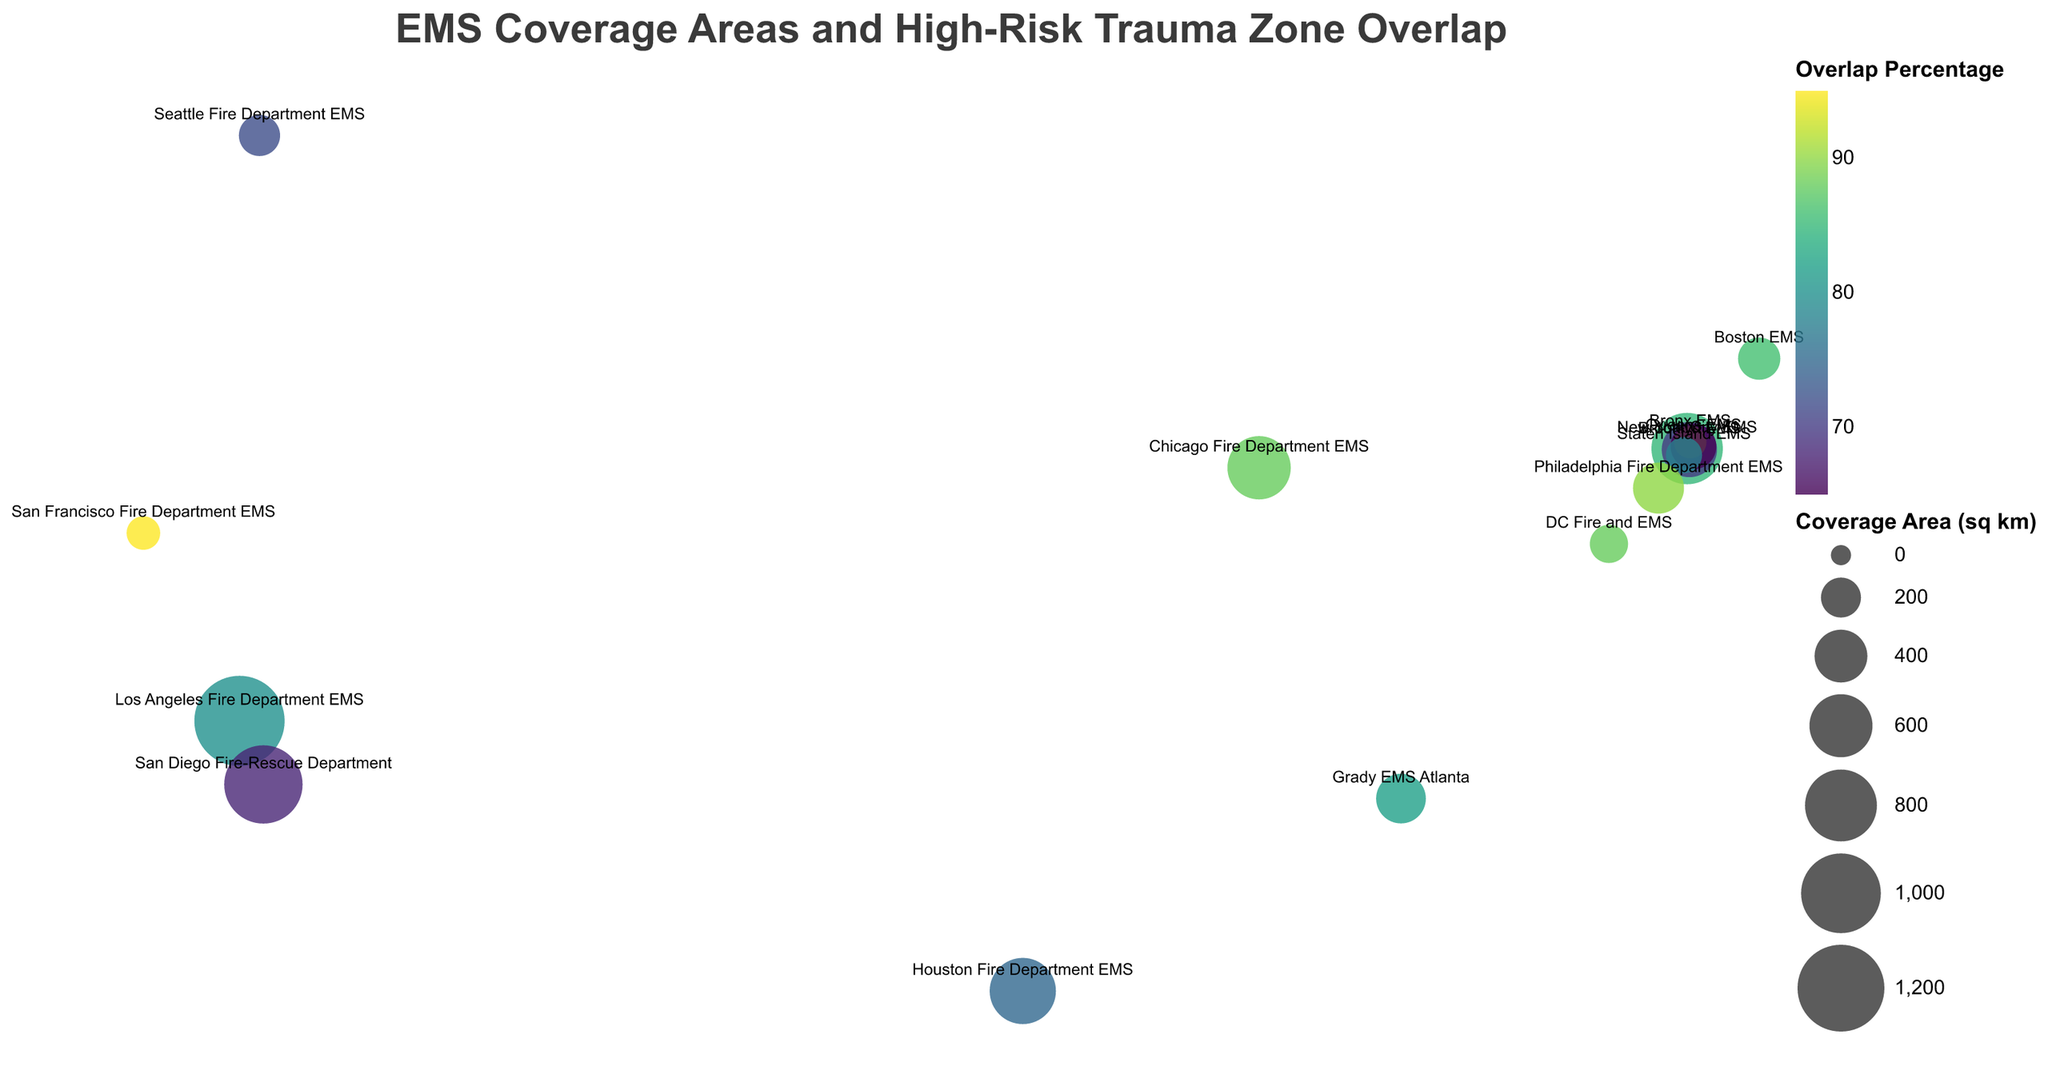What's the title of the figure? The title is located at the top center of the figure.
Answer: "EMS Coverage Areas and High-Risk Trauma Zone Overlap" How many EMS providers are displayed in the figure? The figure uses distinct markers for each EMS provider labeled by city names. Counting these labels gives the total number of EMS providers.
Answer: 15 Which EMS provider has the highest overlap percentage with high-risk trauma zones? The overlap percentage is indicated by the color of the circles. By referring to the color scale, the darkest shade corresponds to the highest overlap percentage. The tooltip can also help find the exact EMS provider.
Answer: San Francisco Fire Department EMS What is the overlap percentage of New York City EMS? Locate New York City EMS on the map, and refer to the tooltip, which will show the overlap percentage directly.
Answer: 85% Which EMS provider covers the smallest area in square kilometers? The size of the circles correlates with the coverage area. The smallest circle will represent the smallest coverage area. The tooltip provides the exact area.
Answer: San Francisco Fire Department EMS Compare the coverage area between Los Angeles Fire Department EMS and San Francisco Fire Department EMS. Which is larger and by how much? Find both EMS providers. The circle for Los Angeles Fire Department EMS is significantly larger. Subtract San Francisco's coverage area (121 sq km) from Los Angeles's (1302 sq km).
Answer: Los Angeles is larger by 1181 sq km Which EMS provider serves the Central District high-risk trauma zone? Each circle is associated with a high-risk trauma zone, and the tooltip shows this information. Locate the "Central District" label in the tooltip.
Answer: Seattle Fire Department EMS What is the average overlap percentage of EMS providers with their respective high-risk trauma zones? Sum all overlap percentages and divide by the number of EMS providers. The percentages are: 85, 70, 92, 65, 78, 88, 80, 75, 82, 90, 86, 95, 72, 88, 68. Sum = 1134. Divide by 15.
Answer: 75.6% Which EMS provider has the highest coverage area in square kilometers? The largest circle indicates the largest coverage area. The tooltip will confirm this.
Answer: Los Angeles Fire Department EMS What's the difference in overlap percentage between Grady EMS Atlanta and Houston Fire Department EMS? Use the tooltip to find the overlap percentages (82% for Grady EMS Atlanta and 75% for Houston Fire Department EMS). Subtract Houston's percentage from Atlanta's.
Answer: 7% 